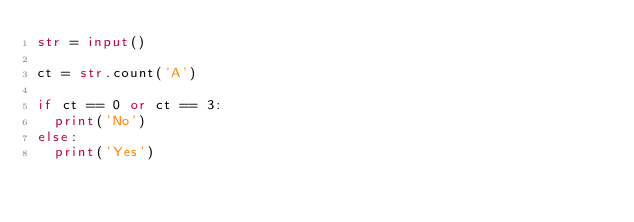<code> <loc_0><loc_0><loc_500><loc_500><_Python_>str = input()

ct = str.count('A')

if ct == 0 or ct == 3:
  print('No')
else:
  print('Yes')</code> 